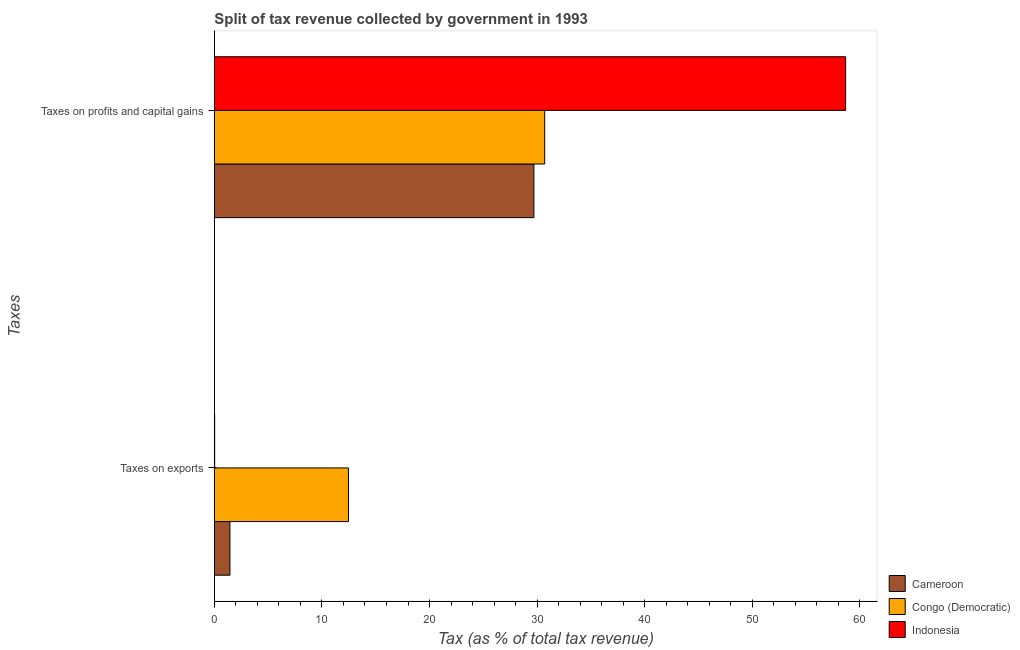How many groups of bars are there?
Offer a terse response. 2. Are the number of bars on each tick of the Y-axis equal?
Provide a short and direct response. Yes. What is the label of the 1st group of bars from the top?
Make the answer very short. Taxes on profits and capital gains. What is the percentage of revenue obtained from taxes on profits and capital gains in Congo (Democratic)?
Keep it short and to the point. 30.71. Across all countries, what is the maximum percentage of revenue obtained from taxes on exports?
Your answer should be compact. 12.47. Across all countries, what is the minimum percentage of revenue obtained from taxes on exports?
Provide a succinct answer. 0.03. In which country was the percentage of revenue obtained from taxes on profits and capital gains minimum?
Keep it short and to the point. Cameroon. What is the total percentage of revenue obtained from taxes on exports in the graph?
Make the answer very short. 13.94. What is the difference between the percentage of revenue obtained from taxes on exports in Indonesia and that in Congo (Democratic)?
Keep it short and to the point. -12.44. What is the difference between the percentage of revenue obtained from taxes on exports in Indonesia and the percentage of revenue obtained from taxes on profits and capital gains in Cameroon?
Provide a succinct answer. -29.67. What is the average percentage of revenue obtained from taxes on exports per country?
Your response must be concise. 4.65. What is the difference between the percentage of revenue obtained from taxes on profits and capital gains and percentage of revenue obtained from taxes on exports in Congo (Democratic)?
Your answer should be very brief. 18.24. What is the ratio of the percentage of revenue obtained from taxes on exports in Indonesia to that in Cameroon?
Your answer should be compact. 0.02. In how many countries, is the percentage of revenue obtained from taxes on profits and capital gains greater than the average percentage of revenue obtained from taxes on profits and capital gains taken over all countries?
Provide a succinct answer. 1. What does the 2nd bar from the top in Taxes on profits and capital gains represents?
Offer a terse response. Congo (Democratic). What does the 3rd bar from the bottom in Taxes on profits and capital gains represents?
Offer a very short reply. Indonesia. What is the difference between two consecutive major ticks on the X-axis?
Give a very brief answer. 10. Where does the legend appear in the graph?
Your response must be concise. Bottom right. What is the title of the graph?
Your answer should be very brief. Split of tax revenue collected by government in 1993. What is the label or title of the X-axis?
Your response must be concise. Tax (as % of total tax revenue). What is the label or title of the Y-axis?
Provide a short and direct response. Taxes. What is the Tax (as % of total tax revenue) of Cameroon in Taxes on exports?
Your answer should be compact. 1.45. What is the Tax (as % of total tax revenue) of Congo (Democratic) in Taxes on exports?
Provide a succinct answer. 12.47. What is the Tax (as % of total tax revenue) of Indonesia in Taxes on exports?
Keep it short and to the point. 0.03. What is the Tax (as % of total tax revenue) in Cameroon in Taxes on profits and capital gains?
Keep it short and to the point. 29.7. What is the Tax (as % of total tax revenue) of Congo (Democratic) in Taxes on profits and capital gains?
Offer a very short reply. 30.71. What is the Tax (as % of total tax revenue) of Indonesia in Taxes on profits and capital gains?
Make the answer very short. 58.68. Across all Taxes, what is the maximum Tax (as % of total tax revenue) in Cameroon?
Your answer should be compact. 29.7. Across all Taxes, what is the maximum Tax (as % of total tax revenue) in Congo (Democratic)?
Your answer should be very brief. 30.71. Across all Taxes, what is the maximum Tax (as % of total tax revenue) in Indonesia?
Keep it short and to the point. 58.68. Across all Taxes, what is the minimum Tax (as % of total tax revenue) in Cameroon?
Make the answer very short. 1.45. Across all Taxes, what is the minimum Tax (as % of total tax revenue) in Congo (Democratic)?
Your answer should be compact. 12.47. Across all Taxes, what is the minimum Tax (as % of total tax revenue) of Indonesia?
Keep it short and to the point. 0.03. What is the total Tax (as % of total tax revenue) of Cameroon in the graph?
Offer a very short reply. 31.15. What is the total Tax (as % of total tax revenue) in Congo (Democratic) in the graph?
Your answer should be compact. 43.17. What is the total Tax (as % of total tax revenue) of Indonesia in the graph?
Provide a succinct answer. 58.71. What is the difference between the Tax (as % of total tax revenue) in Cameroon in Taxes on exports and that in Taxes on profits and capital gains?
Provide a succinct answer. -28.25. What is the difference between the Tax (as % of total tax revenue) in Congo (Democratic) in Taxes on exports and that in Taxes on profits and capital gains?
Make the answer very short. -18.24. What is the difference between the Tax (as % of total tax revenue) of Indonesia in Taxes on exports and that in Taxes on profits and capital gains?
Keep it short and to the point. -58.65. What is the difference between the Tax (as % of total tax revenue) of Cameroon in Taxes on exports and the Tax (as % of total tax revenue) of Congo (Democratic) in Taxes on profits and capital gains?
Provide a succinct answer. -29.26. What is the difference between the Tax (as % of total tax revenue) of Cameroon in Taxes on exports and the Tax (as % of total tax revenue) of Indonesia in Taxes on profits and capital gains?
Give a very brief answer. -57.23. What is the difference between the Tax (as % of total tax revenue) of Congo (Democratic) in Taxes on exports and the Tax (as % of total tax revenue) of Indonesia in Taxes on profits and capital gains?
Offer a very short reply. -46.21. What is the average Tax (as % of total tax revenue) of Cameroon per Taxes?
Provide a short and direct response. 15.58. What is the average Tax (as % of total tax revenue) in Congo (Democratic) per Taxes?
Keep it short and to the point. 21.59. What is the average Tax (as % of total tax revenue) of Indonesia per Taxes?
Your answer should be very brief. 29.35. What is the difference between the Tax (as % of total tax revenue) in Cameroon and Tax (as % of total tax revenue) in Congo (Democratic) in Taxes on exports?
Offer a very short reply. -11.02. What is the difference between the Tax (as % of total tax revenue) of Cameroon and Tax (as % of total tax revenue) of Indonesia in Taxes on exports?
Offer a terse response. 1.42. What is the difference between the Tax (as % of total tax revenue) of Congo (Democratic) and Tax (as % of total tax revenue) of Indonesia in Taxes on exports?
Make the answer very short. 12.44. What is the difference between the Tax (as % of total tax revenue) of Cameroon and Tax (as % of total tax revenue) of Congo (Democratic) in Taxes on profits and capital gains?
Your answer should be compact. -1. What is the difference between the Tax (as % of total tax revenue) of Cameroon and Tax (as % of total tax revenue) of Indonesia in Taxes on profits and capital gains?
Offer a very short reply. -28.98. What is the difference between the Tax (as % of total tax revenue) of Congo (Democratic) and Tax (as % of total tax revenue) of Indonesia in Taxes on profits and capital gains?
Provide a short and direct response. -27.97. What is the ratio of the Tax (as % of total tax revenue) of Cameroon in Taxes on exports to that in Taxes on profits and capital gains?
Give a very brief answer. 0.05. What is the ratio of the Tax (as % of total tax revenue) in Congo (Democratic) in Taxes on exports to that in Taxes on profits and capital gains?
Offer a terse response. 0.41. What is the ratio of the Tax (as % of total tax revenue) in Indonesia in Taxes on exports to that in Taxes on profits and capital gains?
Offer a terse response. 0. What is the difference between the highest and the second highest Tax (as % of total tax revenue) of Cameroon?
Your answer should be very brief. 28.25. What is the difference between the highest and the second highest Tax (as % of total tax revenue) in Congo (Democratic)?
Ensure brevity in your answer.  18.24. What is the difference between the highest and the second highest Tax (as % of total tax revenue) in Indonesia?
Your answer should be very brief. 58.65. What is the difference between the highest and the lowest Tax (as % of total tax revenue) of Cameroon?
Provide a succinct answer. 28.25. What is the difference between the highest and the lowest Tax (as % of total tax revenue) in Congo (Democratic)?
Ensure brevity in your answer.  18.24. What is the difference between the highest and the lowest Tax (as % of total tax revenue) in Indonesia?
Give a very brief answer. 58.65. 